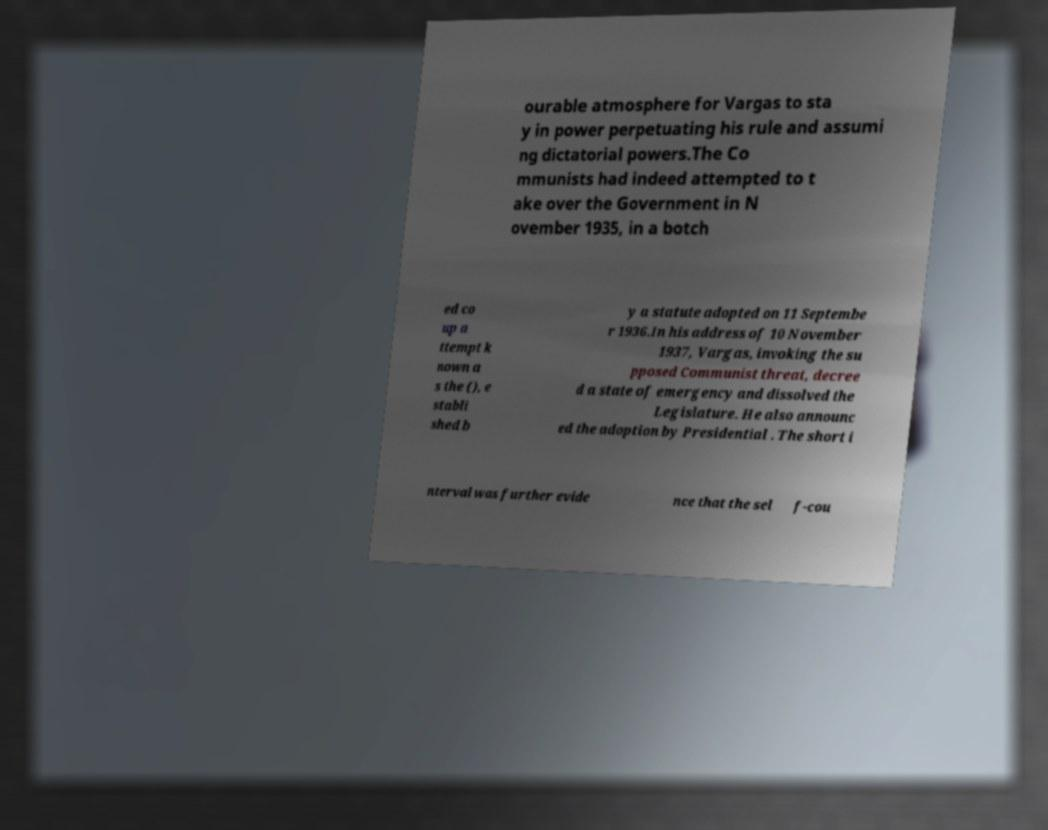Please read and relay the text visible in this image. What does it say? ourable atmosphere for Vargas to sta y in power perpetuating his rule and assumi ng dictatorial powers.The Co mmunists had indeed attempted to t ake over the Government in N ovember 1935, in a botch ed co up a ttempt k nown a s the (), e stabli shed b y a statute adopted on 11 Septembe r 1936.In his address of 10 November 1937, Vargas, invoking the su pposed Communist threat, decree d a state of emergency and dissolved the Legislature. He also announc ed the adoption by Presidential . The short i nterval was further evide nce that the sel f-cou 